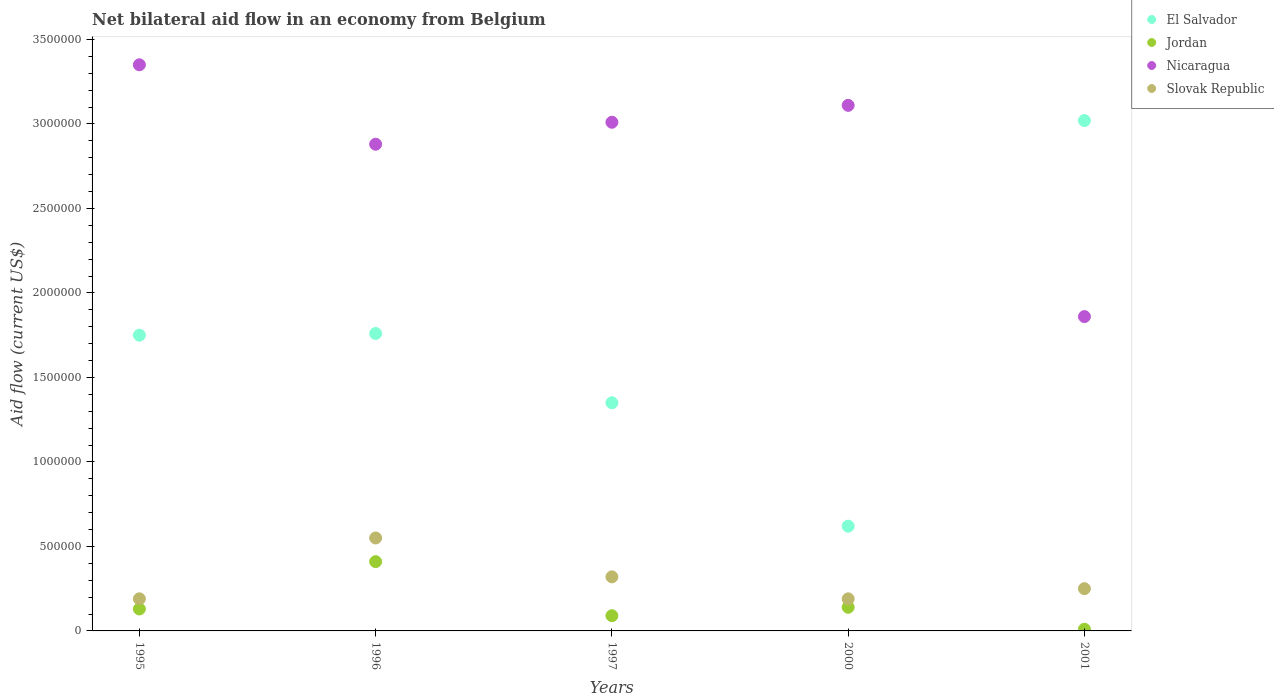How many different coloured dotlines are there?
Make the answer very short. 4. Is the number of dotlines equal to the number of legend labels?
Provide a succinct answer. Yes. In which year was the net bilateral aid flow in Nicaragua maximum?
Offer a very short reply. 1995. What is the total net bilateral aid flow in Slovak Republic in the graph?
Provide a succinct answer. 1.50e+06. What is the average net bilateral aid flow in Slovak Republic per year?
Offer a very short reply. 3.00e+05. What is the ratio of the net bilateral aid flow in El Salvador in 1996 to that in 2000?
Give a very brief answer. 2.84. What is the difference between the highest and the lowest net bilateral aid flow in Nicaragua?
Offer a very short reply. 1.49e+06. In how many years, is the net bilateral aid flow in Jordan greater than the average net bilateral aid flow in Jordan taken over all years?
Your answer should be very brief. 1. Is it the case that in every year, the sum of the net bilateral aid flow in Nicaragua and net bilateral aid flow in Jordan  is greater than the net bilateral aid flow in El Salvador?
Keep it short and to the point. No. Is the net bilateral aid flow in Slovak Republic strictly greater than the net bilateral aid flow in Jordan over the years?
Your answer should be very brief. Yes. Is the net bilateral aid flow in Slovak Republic strictly less than the net bilateral aid flow in Nicaragua over the years?
Make the answer very short. Yes. How many dotlines are there?
Provide a short and direct response. 4. How many years are there in the graph?
Offer a very short reply. 5. What is the difference between two consecutive major ticks on the Y-axis?
Make the answer very short. 5.00e+05. Where does the legend appear in the graph?
Offer a very short reply. Top right. How many legend labels are there?
Your response must be concise. 4. What is the title of the graph?
Give a very brief answer. Net bilateral aid flow in an economy from Belgium. What is the label or title of the X-axis?
Your answer should be very brief. Years. What is the Aid flow (current US$) in El Salvador in 1995?
Provide a succinct answer. 1.75e+06. What is the Aid flow (current US$) of Jordan in 1995?
Offer a very short reply. 1.30e+05. What is the Aid flow (current US$) in Nicaragua in 1995?
Make the answer very short. 3.35e+06. What is the Aid flow (current US$) of Slovak Republic in 1995?
Offer a very short reply. 1.90e+05. What is the Aid flow (current US$) of El Salvador in 1996?
Your answer should be very brief. 1.76e+06. What is the Aid flow (current US$) in Nicaragua in 1996?
Provide a short and direct response. 2.88e+06. What is the Aid flow (current US$) of El Salvador in 1997?
Keep it short and to the point. 1.35e+06. What is the Aid flow (current US$) in Jordan in 1997?
Ensure brevity in your answer.  9.00e+04. What is the Aid flow (current US$) of Nicaragua in 1997?
Provide a succinct answer. 3.01e+06. What is the Aid flow (current US$) in El Salvador in 2000?
Offer a very short reply. 6.20e+05. What is the Aid flow (current US$) of Jordan in 2000?
Your answer should be very brief. 1.40e+05. What is the Aid flow (current US$) of Nicaragua in 2000?
Keep it short and to the point. 3.11e+06. What is the Aid flow (current US$) of Slovak Republic in 2000?
Your response must be concise. 1.90e+05. What is the Aid flow (current US$) of El Salvador in 2001?
Offer a very short reply. 3.02e+06. What is the Aid flow (current US$) of Jordan in 2001?
Keep it short and to the point. 10000. What is the Aid flow (current US$) of Nicaragua in 2001?
Offer a terse response. 1.86e+06. Across all years, what is the maximum Aid flow (current US$) in El Salvador?
Make the answer very short. 3.02e+06. Across all years, what is the maximum Aid flow (current US$) in Nicaragua?
Make the answer very short. 3.35e+06. Across all years, what is the minimum Aid flow (current US$) of El Salvador?
Provide a short and direct response. 6.20e+05. Across all years, what is the minimum Aid flow (current US$) of Nicaragua?
Provide a succinct answer. 1.86e+06. What is the total Aid flow (current US$) in El Salvador in the graph?
Make the answer very short. 8.50e+06. What is the total Aid flow (current US$) in Jordan in the graph?
Provide a succinct answer. 7.80e+05. What is the total Aid flow (current US$) in Nicaragua in the graph?
Your response must be concise. 1.42e+07. What is the total Aid flow (current US$) of Slovak Republic in the graph?
Offer a terse response. 1.50e+06. What is the difference between the Aid flow (current US$) of Jordan in 1995 and that in 1996?
Provide a short and direct response. -2.80e+05. What is the difference between the Aid flow (current US$) of Slovak Republic in 1995 and that in 1996?
Make the answer very short. -3.60e+05. What is the difference between the Aid flow (current US$) in El Salvador in 1995 and that in 1997?
Give a very brief answer. 4.00e+05. What is the difference between the Aid flow (current US$) of Jordan in 1995 and that in 1997?
Provide a short and direct response. 4.00e+04. What is the difference between the Aid flow (current US$) of Nicaragua in 1995 and that in 1997?
Offer a very short reply. 3.40e+05. What is the difference between the Aid flow (current US$) of Slovak Republic in 1995 and that in 1997?
Give a very brief answer. -1.30e+05. What is the difference between the Aid flow (current US$) of El Salvador in 1995 and that in 2000?
Your answer should be compact. 1.13e+06. What is the difference between the Aid flow (current US$) in Jordan in 1995 and that in 2000?
Make the answer very short. -10000. What is the difference between the Aid flow (current US$) of Nicaragua in 1995 and that in 2000?
Keep it short and to the point. 2.40e+05. What is the difference between the Aid flow (current US$) of El Salvador in 1995 and that in 2001?
Provide a short and direct response. -1.27e+06. What is the difference between the Aid flow (current US$) of Jordan in 1995 and that in 2001?
Ensure brevity in your answer.  1.20e+05. What is the difference between the Aid flow (current US$) of Nicaragua in 1995 and that in 2001?
Provide a succinct answer. 1.49e+06. What is the difference between the Aid flow (current US$) of Slovak Republic in 1995 and that in 2001?
Your response must be concise. -6.00e+04. What is the difference between the Aid flow (current US$) in El Salvador in 1996 and that in 1997?
Your answer should be very brief. 4.10e+05. What is the difference between the Aid flow (current US$) of Jordan in 1996 and that in 1997?
Your answer should be compact. 3.20e+05. What is the difference between the Aid flow (current US$) of Slovak Republic in 1996 and that in 1997?
Provide a short and direct response. 2.30e+05. What is the difference between the Aid flow (current US$) in El Salvador in 1996 and that in 2000?
Keep it short and to the point. 1.14e+06. What is the difference between the Aid flow (current US$) in Jordan in 1996 and that in 2000?
Offer a very short reply. 2.70e+05. What is the difference between the Aid flow (current US$) of Nicaragua in 1996 and that in 2000?
Provide a short and direct response. -2.30e+05. What is the difference between the Aid flow (current US$) of Slovak Republic in 1996 and that in 2000?
Keep it short and to the point. 3.60e+05. What is the difference between the Aid flow (current US$) of El Salvador in 1996 and that in 2001?
Make the answer very short. -1.26e+06. What is the difference between the Aid flow (current US$) in Nicaragua in 1996 and that in 2001?
Ensure brevity in your answer.  1.02e+06. What is the difference between the Aid flow (current US$) in Slovak Republic in 1996 and that in 2001?
Give a very brief answer. 3.00e+05. What is the difference between the Aid flow (current US$) in El Salvador in 1997 and that in 2000?
Keep it short and to the point. 7.30e+05. What is the difference between the Aid flow (current US$) of Jordan in 1997 and that in 2000?
Offer a very short reply. -5.00e+04. What is the difference between the Aid flow (current US$) in Slovak Republic in 1997 and that in 2000?
Offer a very short reply. 1.30e+05. What is the difference between the Aid flow (current US$) in El Salvador in 1997 and that in 2001?
Your answer should be very brief. -1.67e+06. What is the difference between the Aid flow (current US$) in Jordan in 1997 and that in 2001?
Ensure brevity in your answer.  8.00e+04. What is the difference between the Aid flow (current US$) in Nicaragua in 1997 and that in 2001?
Offer a very short reply. 1.15e+06. What is the difference between the Aid flow (current US$) in El Salvador in 2000 and that in 2001?
Offer a very short reply. -2.40e+06. What is the difference between the Aid flow (current US$) of Nicaragua in 2000 and that in 2001?
Provide a succinct answer. 1.25e+06. What is the difference between the Aid flow (current US$) in El Salvador in 1995 and the Aid flow (current US$) in Jordan in 1996?
Make the answer very short. 1.34e+06. What is the difference between the Aid flow (current US$) of El Salvador in 1995 and the Aid flow (current US$) of Nicaragua in 1996?
Offer a terse response. -1.13e+06. What is the difference between the Aid flow (current US$) of El Salvador in 1995 and the Aid flow (current US$) of Slovak Republic in 1996?
Your answer should be compact. 1.20e+06. What is the difference between the Aid flow (current US$) of Jordan in 1995 and the Aid flow (current US$) of Nicaragua in 1996?
Your response must be concise. -2.75e+06. What is the difference between the Aid flow (current US$) in Jordan in 1995 and the Aid flow (current US$) in Slovak Republic in 1996?
Keep it short and to the point. -4.20e+05. What is the difference between the Aid flow (current US$) in Nicaragua in 1995 and the Aid flow (current US$) in Slovak Republic in 1996?
Ensure brevity in your answer.  2.80e+06. What is the difference between the Aid flow (current US$) in El Salvador in 1995 and the Aid flow (current US$) in Jordan in 1997?
Provide a succinct answer. 1.66e+06. What is the difference between the Aid flow (current US$) of El Salvador in 1995 and the Aid flow (current US$) of Nicaragua in 1997?
Give a very brief answer. -1.26e+06. What is the difference between the Aid flow (current US$) of El Salvador in 1995 and the Aid flow (current US$) of Slovak Republic in 1997?
Make the answer very short. 1.43e+06. What is the difference between the Aid flow (current US$) in Jordan in 1995 and the Aid flow (current US$) in Nicaragua in 1997?
Make the answer very short. -2.88e+06. What is the difference between the Aid flow (current US$) in Nicaragua in 1995 and the Aid flow (current US$) in Slovak Republic in 1997?
Keep it short and to the point. 3.03e+06. What is the difference between the Aid flow (current US$) in El Salvador in 1995 and the Aid flow (current US$) in Jordan in 2000?
Provide a short and direct response. 1.61e+06. What is the difference between the Aid flow (current US$) in El Salvador in 1995 and the Aid flow (current US$) in Nicaragua in 2000?
Offer a very short reply. -1.36e+06. What is the difference between the Aid flow (current US$) of El Salvador in 1995 and the Aid flow (current US$) of Slovak Republic in 2000?
Give a very brief answer. 1.56e+06. What is the difference between the Aid flow (current US$) of Jordan in 1995 and the Aid flow (current US$) of Nicaragua in 2000?
Your answer should be compact. -2.98e+06. What is the difference between the Aid flow (current US$) of Nicaragua in 1995 and the Aid flow (current US$) of Slovak Republic in 2000?
Provide a succinct answer. 3.16e+06. What is the difference between the Aid flow (current US$) of El Salvador in 1995 and the Aid flow (current US$) of Jordan in 2001?
Offer a very short reply. 1.74e+06. What is the difference between the Aid flow (current US$) in El Salvador in 1995 and the Aid flow (current US$) in Nicaragua in 2001?
Offer a very short reply. -1.10e+05. What is the difference between the Aid flow (current US$) in El Salvador in 1995 and the Aid flow (current US$) in Slovak Republic in 2001?
Your answer should be very brief. 1.50e+06. What is the difference between the Aid flow (current US$) of Jordan in 1995 and the Aid flow (current US$) of Nicaragua in 2001?
Give a very brief answer. -1.73e+06. What is the difference between the Aid flow (current US$) of Jordan in 1995 and the Aid flow (current US$) of Slovak Republic in 2001?
Offer a very short reply. -1.20e+05. What is the difference between the Aid flow (current US$) in Nicaragua in 1995 and the Aid flow (current US$) in Slovak Republic in 2001?
Make the answer very short. 3.10e+06. What is the difference between the Aid flow (current US$) of El Salvador in 1996 and the Aid flow (current US$) of Jordan in 1997?
Provide a succinct answer. 1.67e+06. What is the difference between the Aid flow (current US$) in El Salvador in 1996 and the Aid flow (current US$) in Nicaragua in 1997?
Give a very brief answer. -1.25e+06. What is the difference between the Aid flow (current US$) of El Salvador in 1996 and the Aid flow (current US$) of Slovak Republic in 1997?
Your answer should be compact. 1.44e+06. What is the difference between the Aid flow (current US$) of Jordan in 1996 and the Aid flow (current US$) of Nicaragua in 1997?
Give a very brief answer. -2.60e+06. What is the difference between the Aid flow (current US$) in Jordan in 1996 and the Aid flow (current US$) in Slovak Republic in 1997?
Your answer should be very brief. 9.00e+04. What is the difference between the Aid flow (current US$) of Nicaragua in 1996 and the Aid flow (current US$) of Slovak Republic in 1997?
Give a very brief answer. 2.56e+06. What is the difference between the Aid flow (current US$) in El Salvador in 1996 and the Aid flow (current US$) in Jordan in 2000?
Ensure brevity in your answer.  1.62e+06. What is the difference between the Aid flow (current US$) in El Salvador in 1996 and the Aid flow (current US$) in Nicaragua in 2000?
Offer a very short reply. -1.35e+06. What is the difference between the Aid flow (current US$) of El Salvador in 1996 and the Aid flow (current US$) of Slovak Republic in 2000?
Offer a terse response. 1.57e+06. What is the difference between the Aid flow (current US$) of Jordan in 1996 and the Aid flow (current US$) of Nicaragua in 2000?
Your answer should be compact. -2.70e+06. What is the difference between the Aid flow (current US$) of Nicaragua in 1996 and the Aid flow (current US$) of Slovak Republic in 2000?
Your answer should be compact. 2.69e+06. What is the difference between the Aid flow (current US$) of El Salvador in 1996 and the Aid flow (current US$) of Jordan in 2001?
Your response must be concise. 1.75e+06. What is the difference between the Aid flow (current US$) of El Salvador in 1996 and the Aid flow (current US$) of Slovak Republic in 2001?
Offer a very short reply. 1.51e+06. What is the difference between the Aid flow (current US$) in Jordan in 1996 and the Aid flow (current US$) in Nicaragua in 2001?
Make the answer very short. -1.45e+06. What is the difference between the Aid flow (current US$) of Jordan in 1996 and the Aid flow (current US$) of Slovak Republic in 2001?
Provide a short and direct response. 1.60e+05. What is the difference between the Aid flow (current US$) in Nicaragua in 1996 and the Aid flow (current US$) in Slovak Republic in 2001?
Keep it short and to the point. 2.63e+06. What is the difference between the Aid flow (current US$) in El Salvador in 1997 and the Aid flow (current US$) in Jordan in 2000?
Offer a terse response. 1.21e+06. What is the difference between the Aid flow (current US$) in El Salvador in 1997 and the Aid flow (current US$) in Nicaragua in 2000?
Provide a succinct answer. -1.76e+06. What is the difference between the Aid flow (current US$) in El Salvador in 1997 and the Aid flow (current US$) in Slovak Republic in 2000?
Offer a terse response. 1.16e+06. What is the difference between the Aid flow (current US$) of Jordan in 1997 and the Aid flow (current US$) of Nicaragua in 2000?
Give a very brief answer. -3.02e+06. What is the difference between the Aid flow (current US$) of Jordan in 1997 and the Aid flow (current US$) of Slovak Republic in 2000?
Your answer should be very brief. -1.00e+05. What is the difference between the Aid flow (current US$) in Nicaragua in 1997 and the Aid flow (current US$) in Slovak Republic in 2000?
Provide a short and direct response. 2.82e+06. What is the difference between the Aid flow (current US$) of El Salvador in 1997 and the Aid flow (current US$) of Jordan in 2001?
Provide a succinct answer. 1.34e+06. What is the difference between the Aid flow (current US$) of El Salvador in 1997 and the Aid flow (current US$) of Nicaragua in 2001?
Provide a short and direct response. -5.10e+05. What is the difference between the Aid flow (current US$) in El Salvador in 1997 and the Aid flow (current US$) in Slovak Republic in 2001?
Offer a very short reply. 1.10e+06. What is the difference between the Aid flow (current US$) of Jordan in 1997 and the Aid flow (current US$) of Nicaragua in 2001?
Your response must be concise. -1.77e+06. What is the difference between the Aid flow (current US$) of Nicaragua in 1997 and the Aid flow (current US$) of Slovak Republic in 2001?
Ensure brevity in your answer.  2.76e+06. What is the difference between the Aid flow (current US$) of El Salvador in 2000 and the Aid flow (current US$) of Jordan in 2001?
Offer a terse response. 6.10e+05. What is the difference between the Aid flow (current US$) of El Salvador in 2000 and the Aid flow (current US$) of Nicaragua in 2001?
Keep it short and to the point. -1.24e+06. What is the difference between the Aid flow (current US$) of El Salvador in 2000 and the Aid flow (current US$) of Slovak Republic in 2001?
Offer a very short reply. 3.70e+05. What is the difference between the Aid flow (current US$) of Jordan in 2000 and the Aid flow (current US$) of Nicaragua in 2001?
Make the answer very short. -1.72e+06. What is the difference between the Aid flow (current US$) in Nicaragua in 2000 and the Aid flow (current US$) in Slovak Republic in 2001?
Provide a succinct answer. 2.86e+06. What is the average Aid flow (current US$) of El Salvador per year?
Your answer should be very brief. 1.70e+06. What is the average Aid flow (current US$) of Jordan per year?
Ensure brevity in your answer.  1.56e+05. What is the average Aid flow (current US$) of Nicaragua per year?
Keep it short and to the point. 2.84e+06. What is the average Aid flow (current US$) of Slovak Republic per year?
Give a very brief answer. 3.00e+05. In the year 1995, what is the difference between the Aid flow (current US$) of El Salvador and Aid flow (current US$) of Jordan?
Make the answer very short. 1.62e+06. In the year 1995, what is the difference between the Aid flow (current US$) of El Salvador and Aid flow (current US$) of Nicaragua?
Offer a very short reply. -1.60e+06. In the year 1995, what is the difference between the Aid flow (current US$) of El Salvador and Aid flow (current US$) of Slovak Republic?
Offer a very short reply. 1.56e+06. In the year 1995, what is the difference between the Aid flow (current US$) in Jordan and Aid flow (current US$) in Nicaragua?
Offer a very short reply. -3.22e+06. In the year 1995, what is the difference between the Aid flow (current US$) in Jordan and Aid flow (current US$) in Slovak Republic?
Ensure brevity in your answer.  -6.00e+04. In the year 1995, what is the difference between the Aid flow (current US$) of Nicaragua and Aid flow (current US$) of Slovak Republic?
Ensure brevity in your answer.  3.16e+06. In the year 1996, what is the difference between the Aid flow (current US$) in El Salvador and Aid flow (current US$) in Jordan?
Offer a very short reply. 1.35e+06. In the year 1996, what is the difference between the Aid flow (current US$) of El Salvador and Aid flow (current US$) of Nicaragua?
Offer a terse response. -1.12e+06. In the year 1996, what is the difference between the Aid flow (current US$) in El Salvador and Aid flow (current US$) in Slovak Republic?
Make the answer very short. 1.21e+06. In the year 1996, what is the difference between the Aid flow (current US$) in Jordan and Aid flow (current US$) in Nicaragua?
Ensure brevity in your answer.  -2.47e+06. In the year 1996, what is the difference between the Aid flow (current US$) in Nicaragua and Aid flow (current US$) in Slovak Republic?
Provide a short and direct response. 2.33e+06. In the year 1997, what is the difference between the Aid flow (current US$) of El Salvador and Aid flow (current US$) of Jordan?
Your response must be concise. 1.26e+06. In the year 1997, what is the difference between the Aid flow (current US$) in El Salvador and Aid flow (current US$) in Nicaragua?
Ensure brevity in your answer.  -1.66e+06. In the year 1997, what is the difference between the Aid flow (current US$) of El Salvador and Aid flow (current US$) of Slovak Republic?
Make the answer very short. 1.03e+06. In the year 1997, what is the difference between the Aid flow (current US$) of Jordan and Aid flow (current US$) of Nicaragua?
Your answer should be very brief. -2.92e+06. In the year 1997, what is the difference between the Aid flow (current US$) of Nicaragua and Aid flow (current US$) of Slovak Republic?
Offer a very short reply. 2.69e+06. In the year 2000, what is the difference between the Aid flow (current US$) of El Salvador and Aid flow (current US$) of Nicaragua?
Offer a terse response. -2.49e+06. In the year 2000, what is the difference between the Aid flow (current US$) of Jordan and Aid flow (current US$) of Nicaragua?
Offer a very short reply. -2.97e+06. In the year 2000, what is the difference between the Aid flow (current US$) of Jordan and Aid flow (current US$) of Slovak Republic?
Your response must be concise. -5.00e+04. In the year 2000, what is the difference between the Aid flow (current US$) of Nicaragua and Aid flow (current US$) of Slovak Republic?
Provide a short and direct response. 2.92e+06. In the year 2001, what is the difference between the Aid flow (current US$) of El Salvador and Aid flow (current US$) of Jordan?
Keep it short and to the point. 3.01e+06. In the year 2001, what is the difference between the Aid flow (current US$) of El Salvador and Aid flow (current US$) of Nicaragua?
Offer a terse response. 1.16e+06. In the year 2001, what is the difference between the Aid flow (current US$) in El Salvador and Aid flow (current US$) in Slovak Republic?
Give a very brief answer. 2.77e+06. In the year 2001, what is the difference between the Aid flow (current US$) of Jordan and Aid flow (current US$) of Nicaragua?
Offer a very short reply. -1.85e+06. In the year 2001, what is the difference between the Aid flow (current US$) in Nicaragua and Aid flow (current US$) in Slovak Republic?
Give a very brief answer. 1.61e+06. What is the ratio of the Aid flow (current US$) in Jordan in 1995 to that in 1996?
Your answer should be very brief. 0.32. What is the ratio of the Aid flow (current US$) in Nicaragua in 1995 to that in 1996?
Make the answer very short. 1.16. What is the ratio of the Aid flow (current US$) of Slovak Republic in 1995 to that in 1996?
Give a very brief answer. 0.35. What is the ratio of the Aid flow (current US$) of El Salvador in 1995 to that in 1997?
Offer a very short reply. 1.3. What is the ratio of the Aid flow (current US$) of Jordan in 1995 to that in 1997?
Offer a terse response. 1.44. What is the ratio of the Aid flow (current US$) in Nicaragua in 1995 to that in 1997?
Your response must be concise. 1.11. What is the ratio of the Aid flow (current US$) in Slovak Republic in 1995 to that in 1997?
Provide a succinct answer. 0.59. What is the ratio of the Aid flow (current US$) in El Salvador in 1995 to that in 2000?
Your answer should be very brief. 2.82. What is the ratio of the Aid flow (current US$) of Nicaragua in 1995 to that in 2000?
Ensure brevity in your answer.  1.08. What is the ratio of the Aid flow (current US$) in Slovak Republic in 1995 to that in 2000?
Keep it short and to the point. 1. What is the ratio of the Aid flow (current US$) of El Salvador in 1995 to that in 2001?
Offer a terse response. 0.58. What is the ratio of the Aid flow (current US$) in Nicaragua in 1995 to that in 2001?
Keep it short and to the point. 1.8. What is the ratio of the Aid flow (current US$) of Slovak Republic in 1995 to that in 2001?
Ensure brevity in your answer.  0.76. What is the ratio of the Aid flow (current US$) in El Salvador in 1996 to that in 1997?
Your answer should be compact. 1.3. What is the ratio of the Aid flow (current US$) of Jordan in 1996 to that in 1997?
Keep it short and to the point. 4.56. What is the ratio of the Aid flow (current US$) of Nicaragua in 1996 to that in 1997?
Make the answer very short. 0.96. What is the ratio of the Aid flow (current US$) of Slovak Republic in 1996 to that in 1997?
Make the answer very short. 1.72. What is the ratio of the Aid flow (current US$) of El Salvador in 1996 to that in 2000?
Offer a very short reply. 2.84. What is the ratio of the Aid flow (current US$) of Jordan in 1996 to that in 2000?
Give a very brief answer. 2.93. What is the ratio of the Aid flow (current US$) in Nicaragua in 1996 to that in 2000?
Your answer should be very brief. 0.93. What is the ratio of the Aid flow (current US$) in Slovak Republic in 1996 to that in 2000?
Offer a terse response. 2.89. What is the ratio of the Aid flow (current US$) of El Salvador in 1996 to that in 2001?
Your answer should be compact. 0.58. What is the ratio of the Aid flow (current US$) of Jordan in 1996 to that in 2001?
Provide a succinct answer. 41. What is the ratio of the Aid flow (current US$) of Nicaragua in 1996 to that in 2001?
Keep it short and to the point. 1.55. What is the ratio of the Aid flow (current US$) of El Salvador in 1997 to that in 2000?
Give a very brief answer. 2.18. What is the ratio of the Aid flow (current US$) of Jordan in 1997 to that in 2000?
Offer a terse response. 0.64. What is the ratio of the Aid flow (current US$) of Nicaragua in 1997 to that in 2000?
Keep it short and to the point. 0.97. What is the ratio of the Aid flow (current US$) of Slovak Republic in 1997 to that in 2000?
Offer a terse response. 1.68. What is the ratio of the Aid flow (current US$) of El Salvador in 1997 to that in 2001?
Give a very brief answer. 0.45. What is the ratio of the Aid flow (current US$) in Jordan in 1997 to that in 2001?
Your answer should be compact. 9. What is the ratio of the Aid flow (current US$) in Nicaragua in 1997 to that in 2001?
Your answer should be very brief. 1.62. What is the ratio of the Aid flow (current US$) in Slovak Republic in 1997 to that in 2001?
Make the answer very short. 1.28. What is the ratio of the Aid flow (current US$) of El Salvador in 2000 to that in 2001?
Give a very brief answer. 0.21. What is the ratio of the Aid flow (current US$) of Jordan in 2000 to that in 2001?
Offer a very short reply. 14. What is the ratio of the Aid flow (current US$) in Nicaragua in 2000 to that in 2001?
Make the answer very short. 1.67. What is the ratio of the Aid flow (current US$) in Slovak Republic in 2000 to that in 2001?
Provide a short and direct response. 0.76. What is the difference between the highest and the second highest Aid flow (current US$) of El Salvador?
Your response must be concise. 1.26e+06. What is the difference between the highest and the second highest Aid flow (current US$) in Jordan?
Your response must be concise. 2.70e+05. What is the difference between the highest and the second highest Aid flow (current US$) of Nicaragua?
Give a very brief answer. 2.40e+05. What is the difference between the highest and the lowest Aid flow (current US$) in El Salvador?
Keep it short and to the point. 2.40e+06. What is the difference between the highest and the lowest Aid flow (current US$) in Nicaragua?
Provide a succinct answer. 1.49e+06. What is the difference between the highest and the lowest Aid flow (current US$) of Slovak Republic?
Your answer should be very brief. 3.60e+05. 